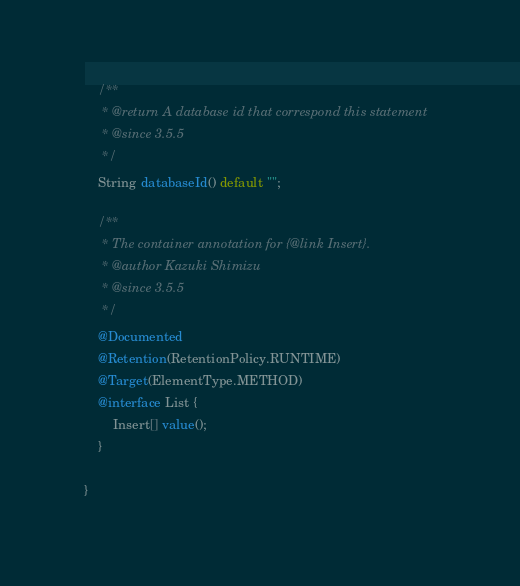Convert code to text. <code><loc_0><loc_0><loc_500><loc_500><_Java_>
    /**
     * @return A database id that correspond this statement
     * @since 3.5.5
     */
    String databaseId() default "";

    /**
     * The container annotation for {@link Insert}.
     * @author Kazuki Shimizu
     * @since 3.5.5
     */
    @Documented
    @Retention(RetentionPolicy.RUNTIME)
    @Target(ElementType.METHOD)
    @interface List {
        Insert[] value();
    }

}
</code> 